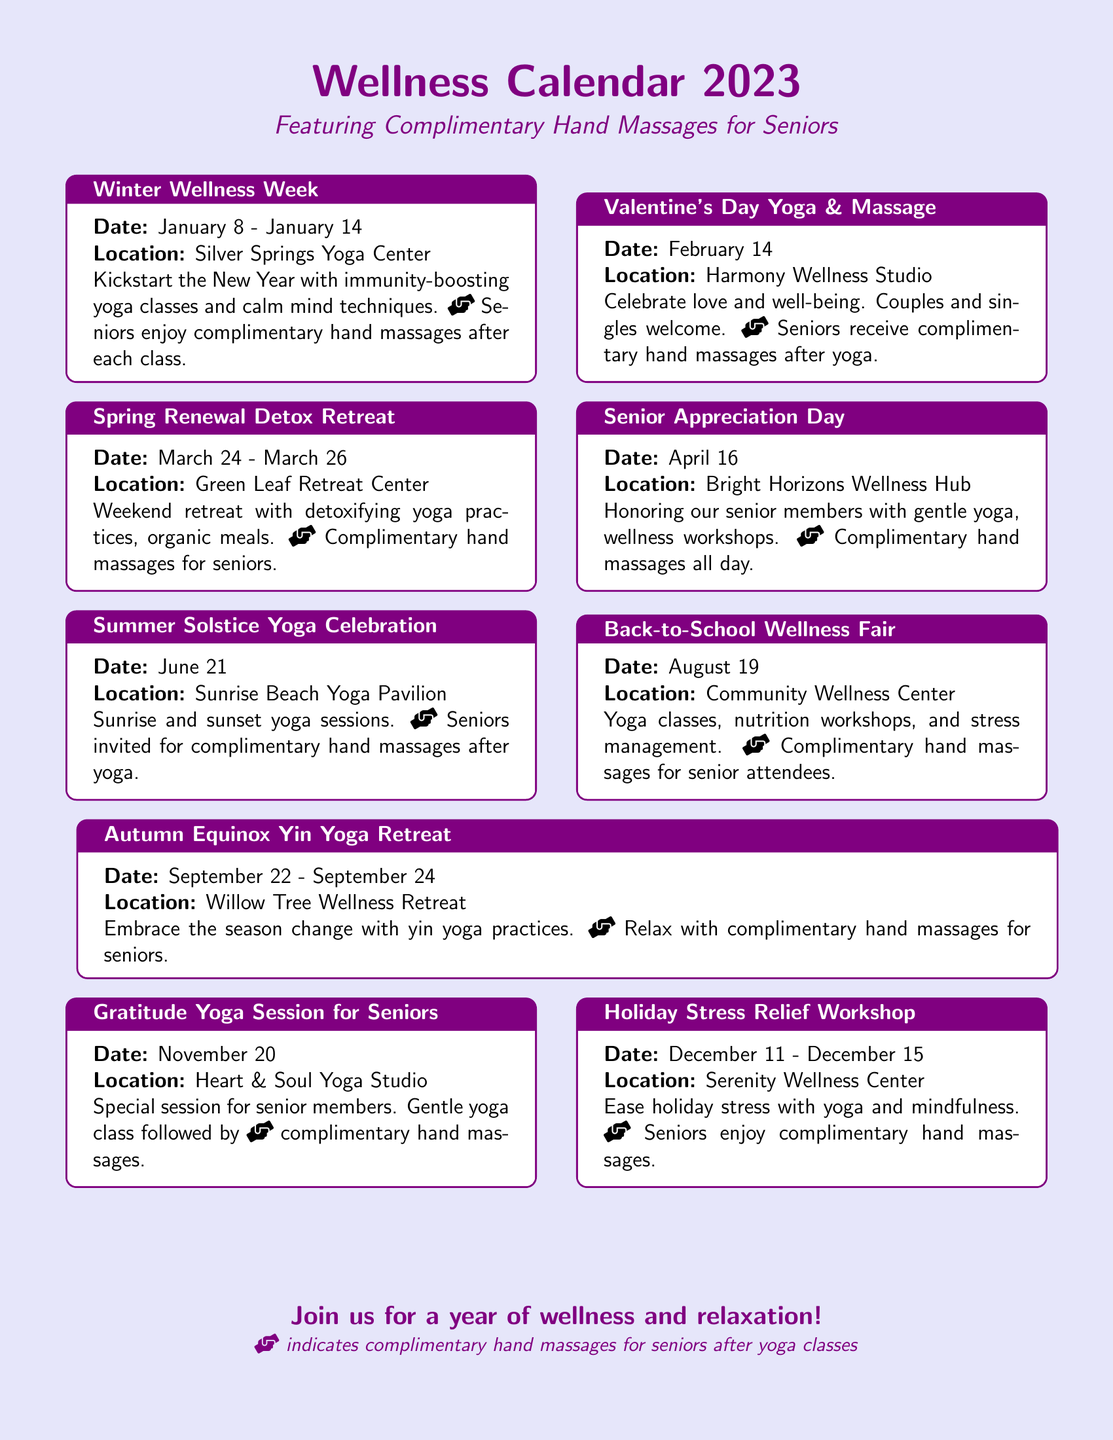What is the title of the first event? The title of the first event is "Winter Wellness Week".
Answer: Winter Wellness Week When is the Senior Appreciation Day scheduled? Senior Appreciation Day is scheduled for April 16.
Answer: April 16 How many days does the Spring Renewal Detox Retreat last? The Spring Renewal Detox Retreat lasts for three days, from March 24 to March 26.
Answer: Three days Which center hosts the Holiday Stress Relief Workshop? The Holiday Stress Relief Workshop is hosted at Serenity Wellness Center.
Answer: Serenity Wellness Center What is the main activity during the Summer Solstice Yoga Celebration? The main activity during the Summer Solstice Yoga Celebration is sunrise and sunset yoga sessions.
Answer: Sunrise and sunset yoga sessions Which event includes wellness workshops for seniors? The event that includes wellness workshops for seniors is Senior Appreciation Day.
Answer: Senior Appreciation Day How many events offer complimentary hand massages for seniors? There are a total of eight events that offer complimentary hand massages for seniors.
Answer: Eight events What date marks the Autumn Equinox Yin Yoga Retreat? The Autumn Equinox Yin Yoga Retreat is marked on September 22 to September 24.
Answer: September 22 - September 24 